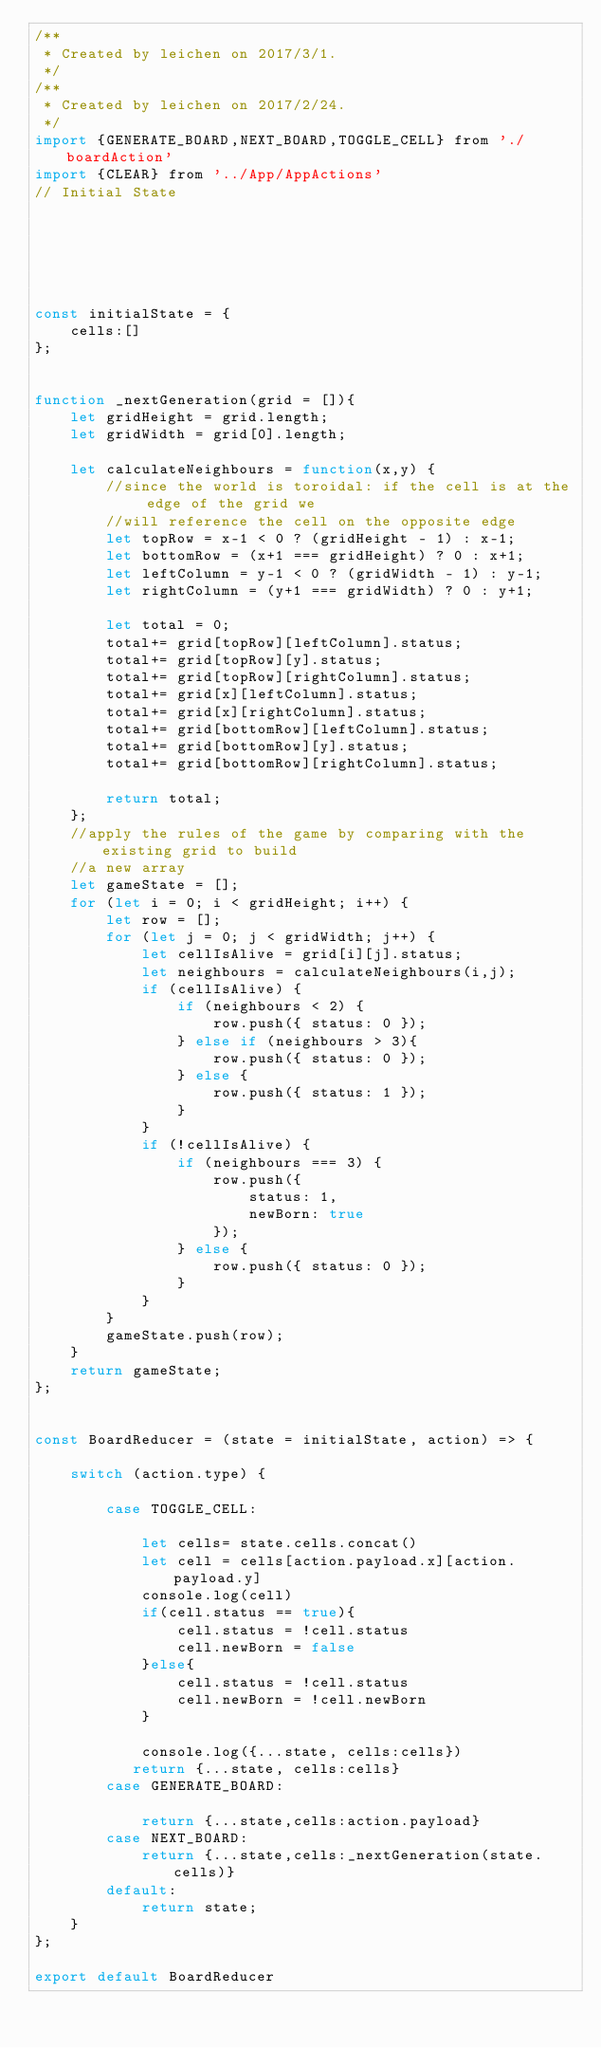<code> <loc_0><loc_0><loc_500><loc_500><_JavaScript_>/**
 * Created by leichen on 2017/3/1.
 */
/**
 * Created by leichen on 2017/2/24.
 */
import {GENERATE_BOARD,NEXT_BOARD,TOGGLE_CELL} from './boardAction'
import {CLEAR} from '../App/AppActions'
// Initial State






const initialState = {
    cells:[]
};


function _nextGeneration(grid = []){
    let gridHeight = grid.length;
    let gridWidth = grid[0].length;

    let calculateNeighbours = function(x,y) {
        //since the world is toroidal: if the cell is at the edge of the grid we
        //will reference the cell on the opposite edge
        let topRow = x-1 < 0 ? (gridHeight - 1) : x-1;
        let bottomRow = (x+1 === gridHeight) ? 0 : x+1;
        let leftColumn = y-1 < 0 ? (gridWidth - 1) : y-1;
        let rightColumn = (y+1 === gridWidth) ? 0 : y+1;

        let total = 0;
        total+= grid[topRow][leftColumn].status;
        total+= grid[topRow][y].status;
        total+= grid[topRow][rightColumn].status;
        total+= grid[x][leftColumn].status;
        total+= grid[x][rightColumn].status;
        total+= grid[bottomRow][leftColumn].status;
        total+= grid[bottomRow][y].status;
        total+= grid[bottomRow][rightColumn].status;

        return total;
    };
    //apply the rules of the game by comparing with the existing grid to build
    //a new array
    let gameState = [];
    for (let i = 0; i < gridHeight; i++) {
        let row = [];
        for (let j = 0; j < gridWidth; j++) {
            let cellIsAlive = grid[i][j].status;
            let neighbours = calculateNeighbours(i,j);
            if (cellIsAlive) {
                if (neighbours < 2) {
                    row.push({ status: 0 });
                } else if (neighbours > 3){
                    row.push({ status: 0 });
                } else {
                    row.push({ status: 1 });
                }
            }
            if (!cellIsAlive) {
                if (neighbours === 3) {
                    row.push({
                        status: 1,
                        newBorn: true
                    });
                } else {
                    row.push({ status: 0 });
                }
            }
        }
        gameState.push(row);
    }
    return gameState;
};


const BoardReducer = (state = initialState, action) => {

    switch (action.type) {

        case TOGGLE_CELL:

            let cells= state.cells.concat()
            let cell = cells[action.payload.x][action.payload.y]
            console.log(cell)
            if(cell.status == true){
                cell.status = !cell.status
                cell.newBorn = false
            }else{
                cell.status = !cell.status
                cell.newBorn = !cell.newBorn
            }

            console.log({...state, cells:cells})
           return {...state, cells:cells}
        case GENERATE_BOARD:

            return {...state,cells:action.payload}
        case NEXT_BOARD:
            return {...state,cells:_nextGeneration(state.cells)}
        default:
            return state;
    }
};

export default BoardReducer</code> 